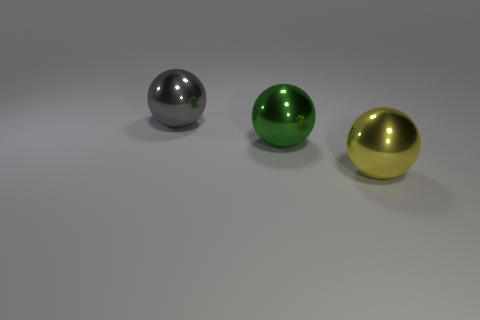Add 1 small cyan things. How many objects exist? 4 Subtract 1 spheres. How many spheres are left? 2 Subtract all red balls. Subtract all green cubes. How many balls are left? 3 Subtract all green cylinders. How many green spheres are left? 1 Subtract all tiny yellow balls. Subtract all gray things. How many objects are left? 2 Add 1 large green metallic spheres. How many large green metallic spheres are left? 2 Add 3 big green shiny things. How many big green shiny things exist? 4 Subtract all gray balls. How many balls are left? 2 Subtract 0 purple cubes. How many objects are left? 3 